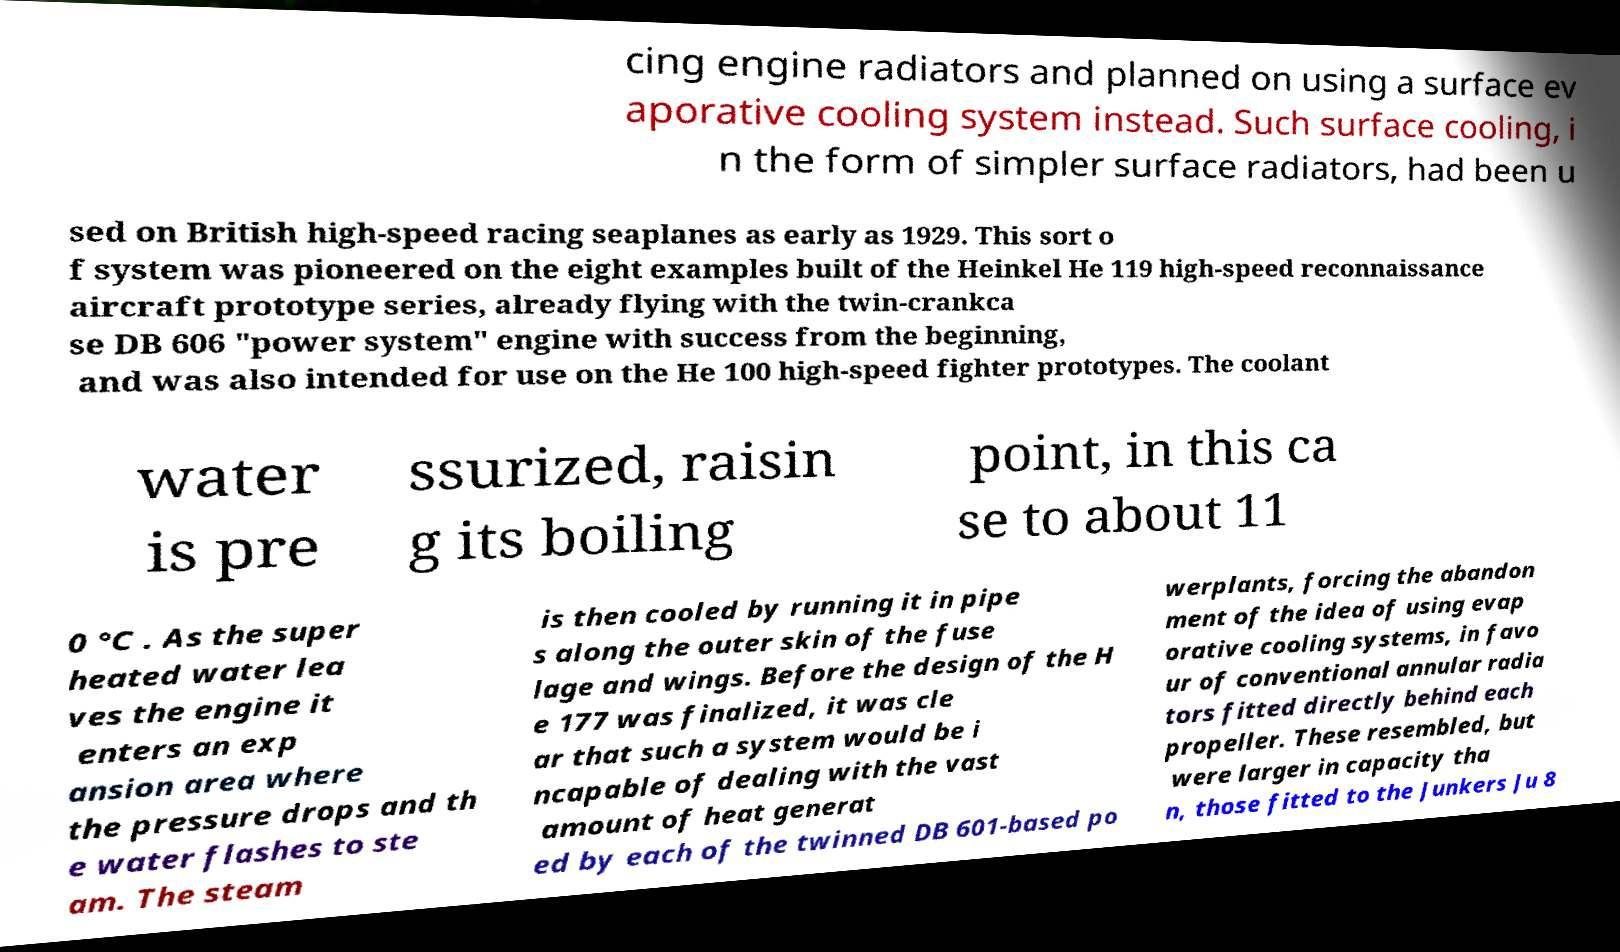There's text embedded in this image that I need extracted. Can you transcribe it verbatim? cing engine radiators and planned on using a surface ev aporative cooling system instead. Such surface cooling, i n the form of simpler surface radiators, had been u sed on British high-speed racing seaplanes as early as 1929. This sort o f system was pioneered on the eight examples built of the Heinkel He 119 high-speed reconnaissance aircraft prototype series, already flying with the twin-crankca se DB 606 "power system" engine with success from the beginning, and was also intended for use on the He 100 high-speed fighter prototypes. The coolant water is pre ssurized, raisin g its boiling point, in this ca se to about 11 0 °C . As the super heated water lea ves the engine it enters an exp ansion area where the pressure drops and th e water flashes to ste am. The steam is then cooled by running it in pipe s along the outer skin of the fuse lage and wings. Before the design of the H e 177 was finalized, it was cle ar that such a system would be i ncapable of dealing with the vast amount of heat generat ed by each of the twinned DB 601-based po werplants, forcing the abandon ment of the idea of using evap orative cooling systems, in favo ur of conventional annular radia tors fitted directly behind each propeller. These resembled, but were larger in capacity tha n, those fitted to the Junkers Ju 8 